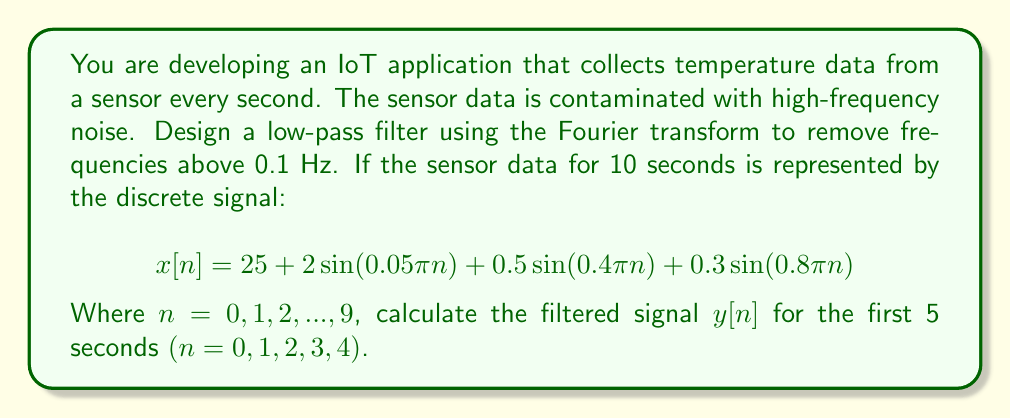Help me with this question. To solve this problem, we'll follow these steps:

1) First, we need to compute the Discrete Fourier Transform (DFT) of the signal $x[n]$. The DFT is given by:

   $$X[k] = \sum_{n=0}^{N-1} x[n]e^{-j2\pi kn/N}$$

   Where $N = 10$ (total number of samples).

2) The frequencies corresponding to each $k$ are:

   $$f_k = \frac{k}{N\Delta t} = \frac{k}{10}$$ Hz

   Where $\Delta t = 1$ second (sampling interval).

3) We want to keep frequencies below 0.1 Hz. This corresponds to $k \leq 1$.

4) We'll create a low-pass filter $H[k]$:

   $$H[k] = \begin{cases} 
   1, & \text{if } |f_k| \leq 0.1 \text{ Hz} \\
   0, & \text{otherwise}
   \end{cases}$$

5) Apply the filter in the frequency domain:

   $$Y[k] = X[k]H[k]$$

6) Compute the inverse DFT to get the filtered signal:

   $$y[n] = \frac{1}{N}\sum_{k=0}^{N-1} Y[k]e^{j2\pi kn/N}$$

7) For $x[n] = 25 + 2\sin(0.05\pi n) + 0.5\sin(0.4\pi n) + 0.3\sin(0.8\pi n)$:
   
   - The DC component (25) corresponds to $k=0$ (0 Hz)
   - $2\sin(0.05\pi n)$ corresponds to 0.025 Hz
   - $0.5\sin(0.4\pi n)$ corresponds to 0.2 Hz
   - $0.3\sin(0.8\pi n)$ corresponds to 0.4 Hz

8) After filtering, only the DC component and the 0.025 Hz component will remain.

9) Therefore, the filtered signal will be:

   $$y[n] \approx 25 + 2\sin(0.05\pi n)$$

10) Calculate $y[n]$ for $n = 0, 1, 2, 3, 4$:

    $y[0] = 25 + 2\sin(0) = 25$
    $y[1] = 25 + 2\sin(0.05\pi) \approx 25.3142$
    $y[2] = 25 + 2\sin(0.1\pi) \approx 25.6180$
    $y[3] = 25 + 2\sin(0.15\pi) \approx 25.9024$
    $y[4] = 25 + 2\sin(0.2\pi) \approx 26.1608$
Answer: The filtered signal $y[n]$ for the first 5 seconds $(n = 0, 1, 2, 3, 4)$ is approximately:

$y[0] = 25.0000$
$y[1] = 25.3142$
$y[2] = 25.6180$
$y[3] = 25.9024$
$y[4] = 26.1608$ 